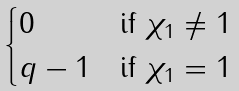Convert formula to latex. <formula><loc_0><loc_0><loc_500><loc_500>\begin{cases} 0 & \text {if} \ \chi _ { 1 } \neq 1 \\ q - 1 & \text {if} \ \chi _ { 1 } = 1 \end{cases}</formula> 